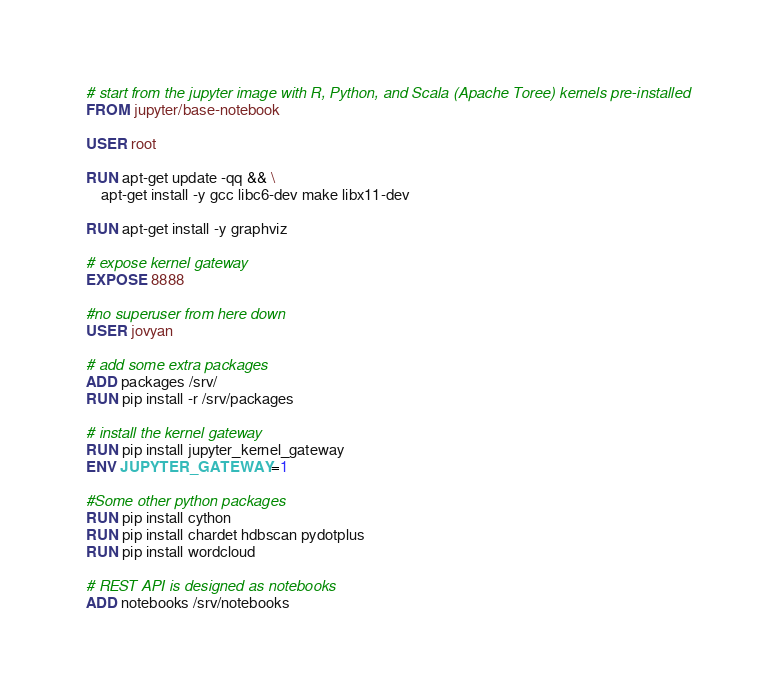Convert code to text. <code><loc_0><loc_0><loc_500><loc_500><_Dockerfile_># start from the jupyter image with R, Python, and Scala (Apache Toree) kernels pre-installed
FROM jupyter/base-notebook

USER root

RUN apt-get update -qq && \
    apt-get install -y gcc libc6-dev make libx11-dev

RUN apt-get install -y graphviz

# expose kernel gateway 
EXPOSE 8888

#no superuser from here down
USER jovyan

# add some extra packages
ADD packages /srv/
RUN pip install -r /srv/packages

# install the kernel gateway
RUN pip install jupyter_kernel_gateway
ENV JUPYTER_GATEWAY=1

#Some other python packages
RUN pip install cython
RUN pip install chardet hdbscan pydotplus
RUN pip install wordcloud

# REST API is designed as notebooks
ADD notebooks /srv/notebooks


</code> 